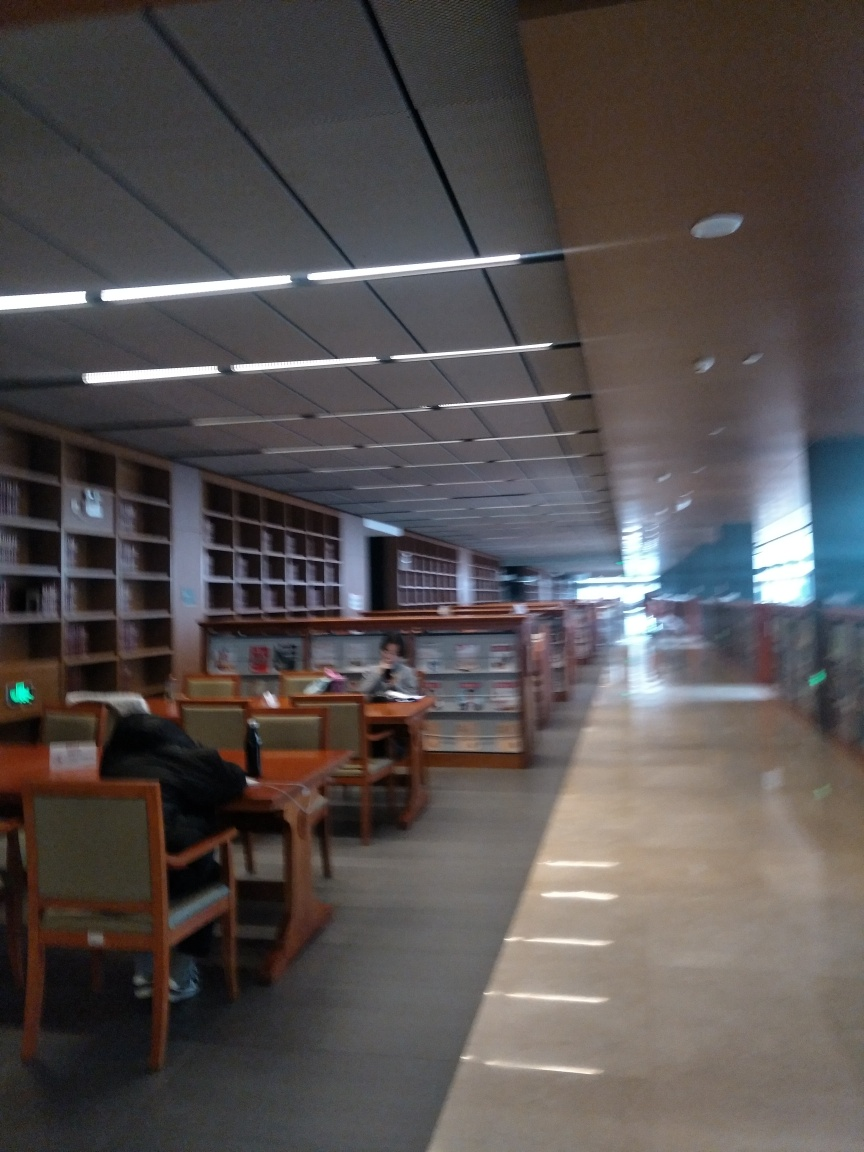How many people can you see in this photo? In this photograph, there are at least two people visible, each engaged in quiet activities, presumably studying or reading. What can you tell about the atmosphere of this place? The atmosphere appears serene and scholarly. The layout and furnishing suggest an environment optimized for concentration and learning, with minimal distractions. 